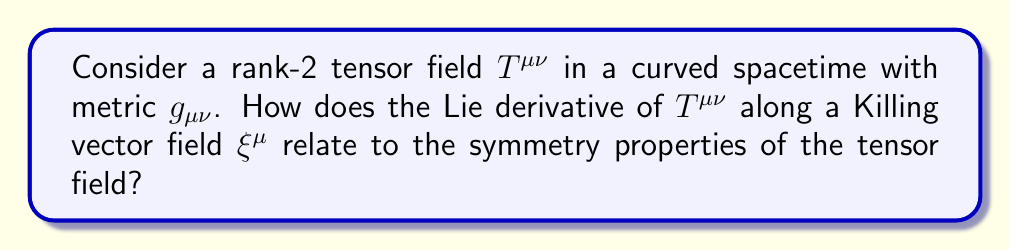What is the answer to this math problem? To analyze this problem, let's follow these steps:

1) First, recall that a Killing vector field $\xi^{\mu}$ satisfies the Killing equation:

   $$\nabla_{\mu}\xi_{\nu} + \nabla_{\nu}\xi_{\mu} = 0$$

2) The Lie derivative of a rank-2 tensor field $T^{\mu\nu}$ along a vector field $\xi^{\mu}$ is given by:

   $$\mathcal{L}_{\xi}T^{\mu\nu} = \xi^{\lambda}\nabla_{\lambda}T^{\mu\nu} - T^{\lambda\nu}\nabla_{\lambda}\xi^{\mu} - T^{\mu\lambda}\nabla_{\lambda}\xi^{\nu}$$

3) If $\xi^{\mu}$ is a Killing vector field, it generates an isometry of the spacetime. This means that the Lie derivative of the metric along $\xi^{\mu}$ vanishes:

   $$\mathcal{L}_{\xi}g_{\mu\nu} = 0$$

4) Now, if the tensor field $T^{\mu\nu}$ is invariant under the isometry generated by $\xi^{\mu}$, then its Lie derivative along $\xi^{\mu}$ should also vanish:

   $$\mathcal{L}_{\xi}T^{\mu\nu} = 0$$

5) This condition, $\mathcal{L}_{\xi}T^{\mu\nu} = 0$, is a mathematical expression of the symmetry of the tensor field $T^{\mu\nu}$ with respect to the isometry generated by $\xi^{\mu}$.

6) In the context of your research on exotic materials, this could represent, for example, the invariance of a stress-energy tensor under certain spacetime symmetries in a curved background.

7) If $\mathcal{L}_{\xi}T^{\mu\nu} = 0$ holds for all Killing vector fields $\xi^{\mu}$ in the spacetime, then $T^{\mu\nu}$ is said to have the same symmetries as the spacetime itself.
Answer: $\mathcal{L}_{\xi}T^{\mu\nu} = 0$ for Killing vector fields $\xi^{\mu}$ 